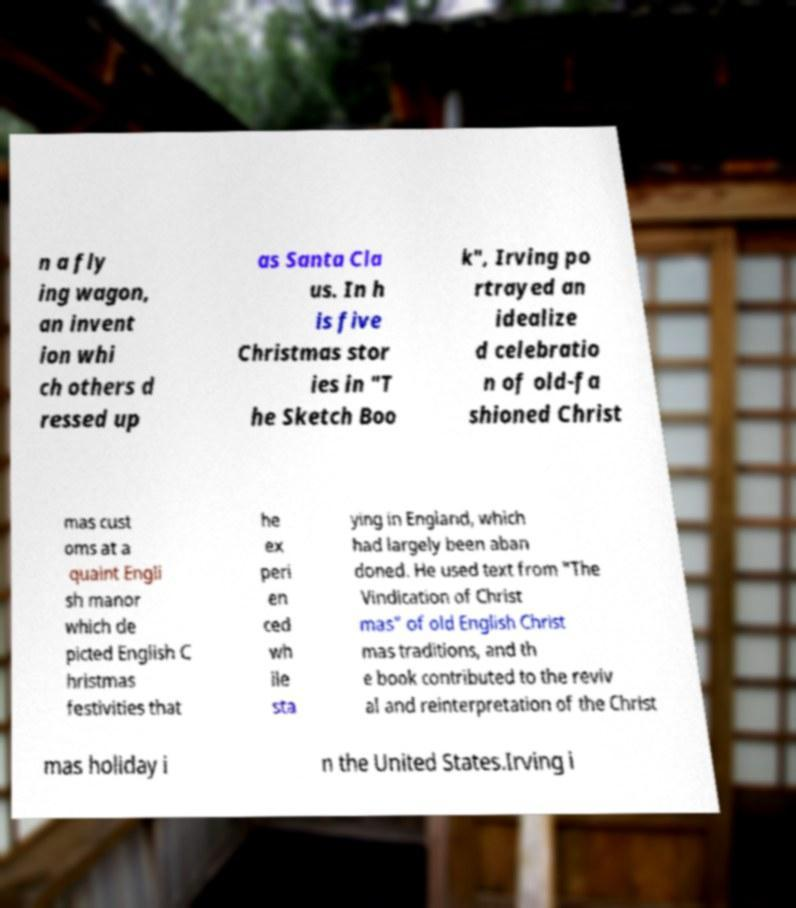Please read and relay the text visible in this image. What does it say? n a fly ing wagon, an invent ion whi ch others d ressed up as Santa Cla us. In h is five Christmas stor ies in "T he Sketch Boo k", Irving po rtrayed an idealize d celebratio n of old-fa shioned Christ mas cust oms at a quaint Engli sh manor which de picted English C hristmas festivities that he ex peri en ced wh ile sta ying in England, which had largely been aban doned. He used text from "The Vindication of Christ mas" of old English Christ mas traditions, and th e book contributed to the reviv al and reinterpretation of the Christ mas holiday i n the United States.Irving i 